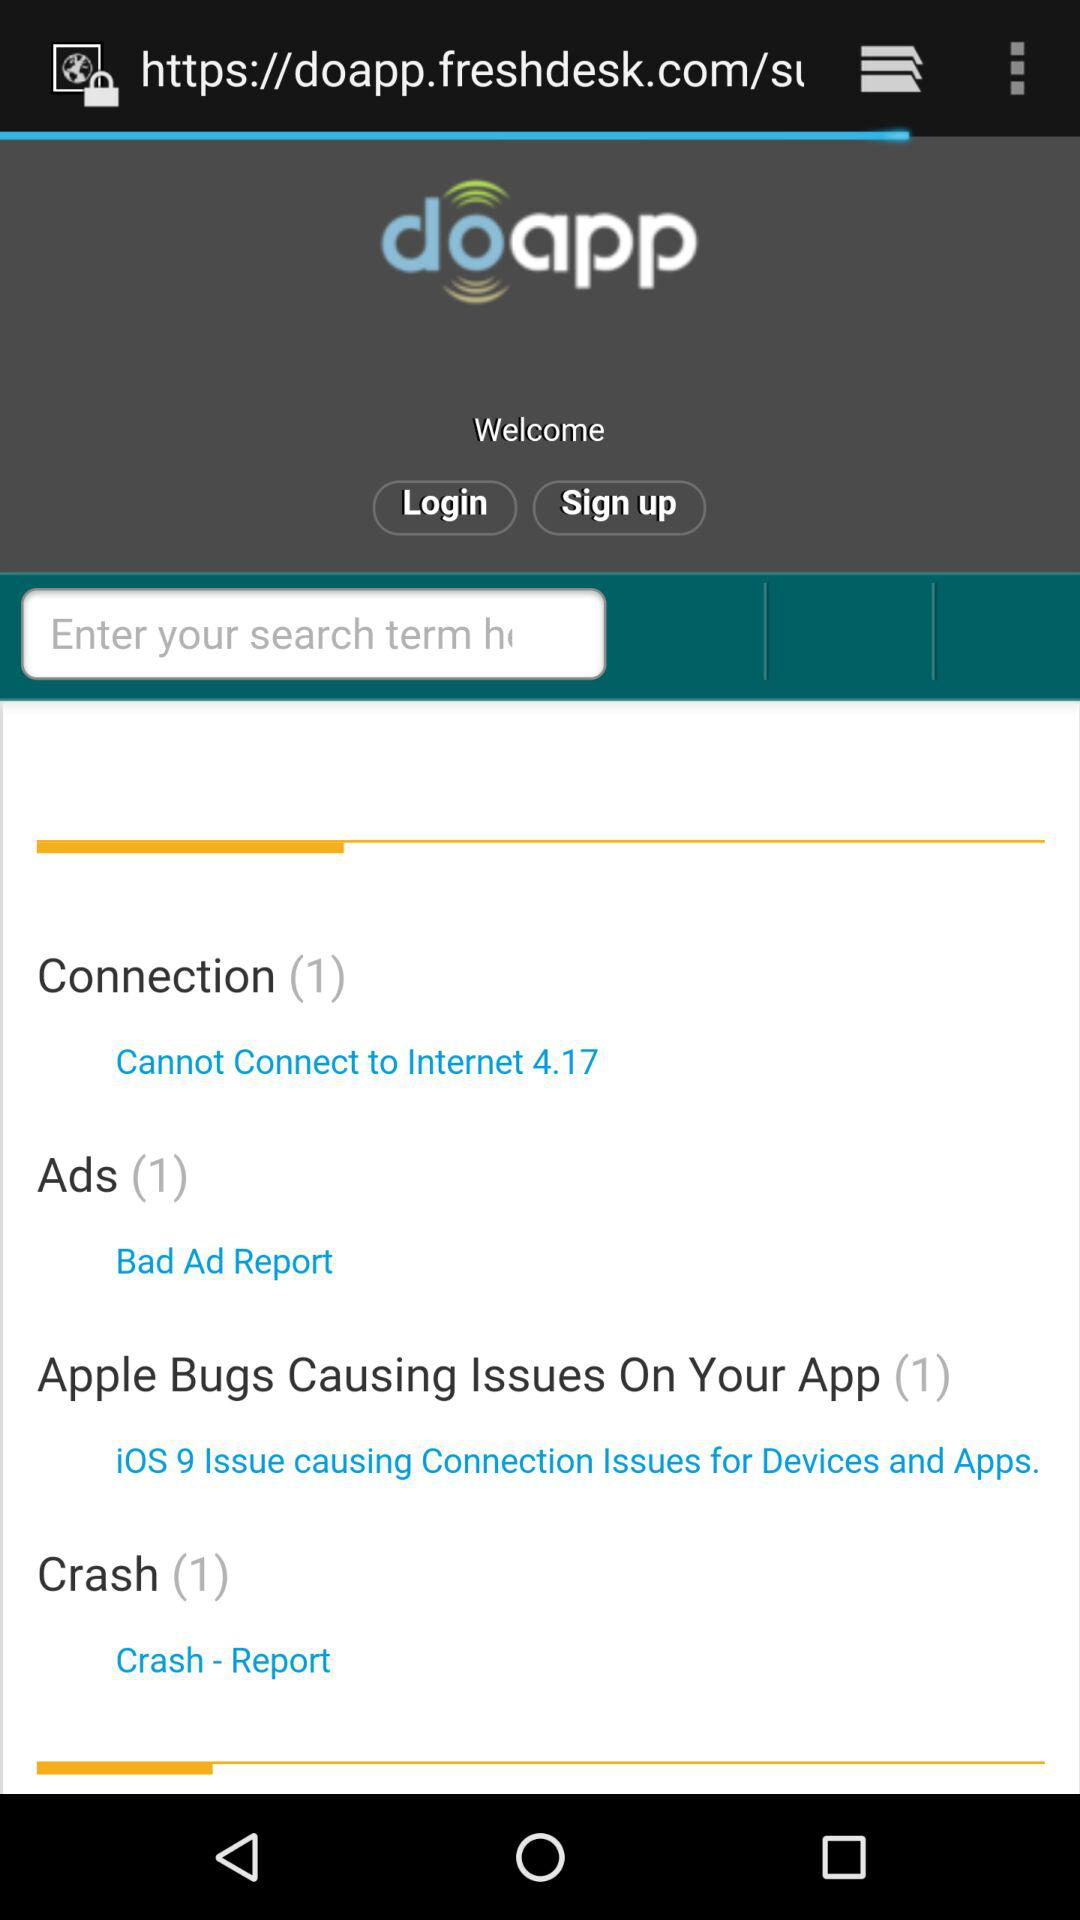What is the website address? The website address is "https://doapp.freshdesk.com/s". 